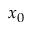Convert formula to latex. <formula><loc_0><loc_0><loc_500><loc_500>x _ { 0 }</formula> 